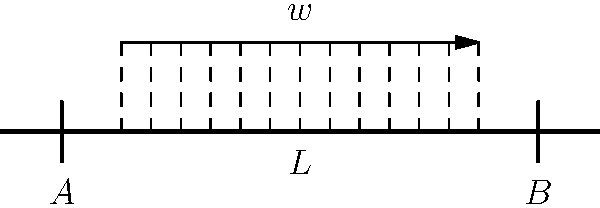In a large-scale construction project for a Russian corporate client, a simply supported beam of length $L$ is subjected to a uniformly distributed load $w$ across its central portion, as shown in the diagram. If the maximum bending stress in the beam occurs at its midspan, express this stress in terms of $w$, $L$, and the beam's section modulus $S$. How might this stress analysis impact the legal considerations for the project's structural integrity? To determine the maximum bending stress, we'll follow these steps:

1) For a simply supported beam with a uniformly distributed load, the maximum bending moment occurs at the midspan.

2) The length of the loaded portion is $0.6L$ (from $0.2L$ to $0.8L$).

3) The total load on the beam is $P = 0.6Lw$.

4) For a centrally loaded beam, the maximum bending moment is:

   $$M_{max} = \frac{PL}{4} = \frac{0.6Lw \cdot L}{4} = 0.15wL^2$$

5) The bending stress is related to the bending moment and section modulus by:

   $$\sigma = \frac{M}{S}$$

6) Substituting the maximum moment:

   $$\sigma_{max} = \frac{0.15wL^2}{S}$$

This stress analysis is crucial for ensuring the structural integrity of the project. From a legal perspective, it helps in:

1) Demonstrating compliance with Russian building codes and standards.
2) Assessing potential liability risks associated with structural failure.
3) Drafting appropriate contractual clauses related to structural performance and warranties.
4) Determining insurance requirements for the project.
Answer: $\sigma_{max} = \frac{0.15wL^2}{S}$ 